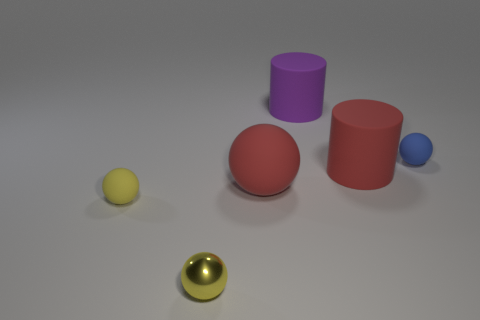What material is the thing to the left of the small shiny object?
Offer a very short reply. Rubber. Is the number of yellow things less than the number of brown shiny cubes?
Offer a very short reply. No. What is the size of the thing that is behind the big red cylinder and on the right side of the big purple cylinder?
Your response must be concise. Small. There is a red rubber object behind the red matte sphere that is to the left of the red matte object right of the purple rubber cylinder; what is its size?
Make the answer very short. Large. How many other objects are the same color as the large rubber sphere?
Offer a very short reply. 1. Do the thing to the left of the tiny yellow metal object and the tiny metal thing have the same color?
Keep it short and to the point. Yes. How many things are small purple matte spheres or large rubber spheres?
Give a very brief answer. 1. The small matte thing that is behind the yellow matte ball is what color?
Provide a short and direct response. Blue. Are there fewer tiny yellow objects that are on the right side of the yellow shiny object than brown matte cubes?
Keep it short and to the point. No. What size is the ball that is the same color as the small shiny thing?
Provide a succinct answer. Small. 